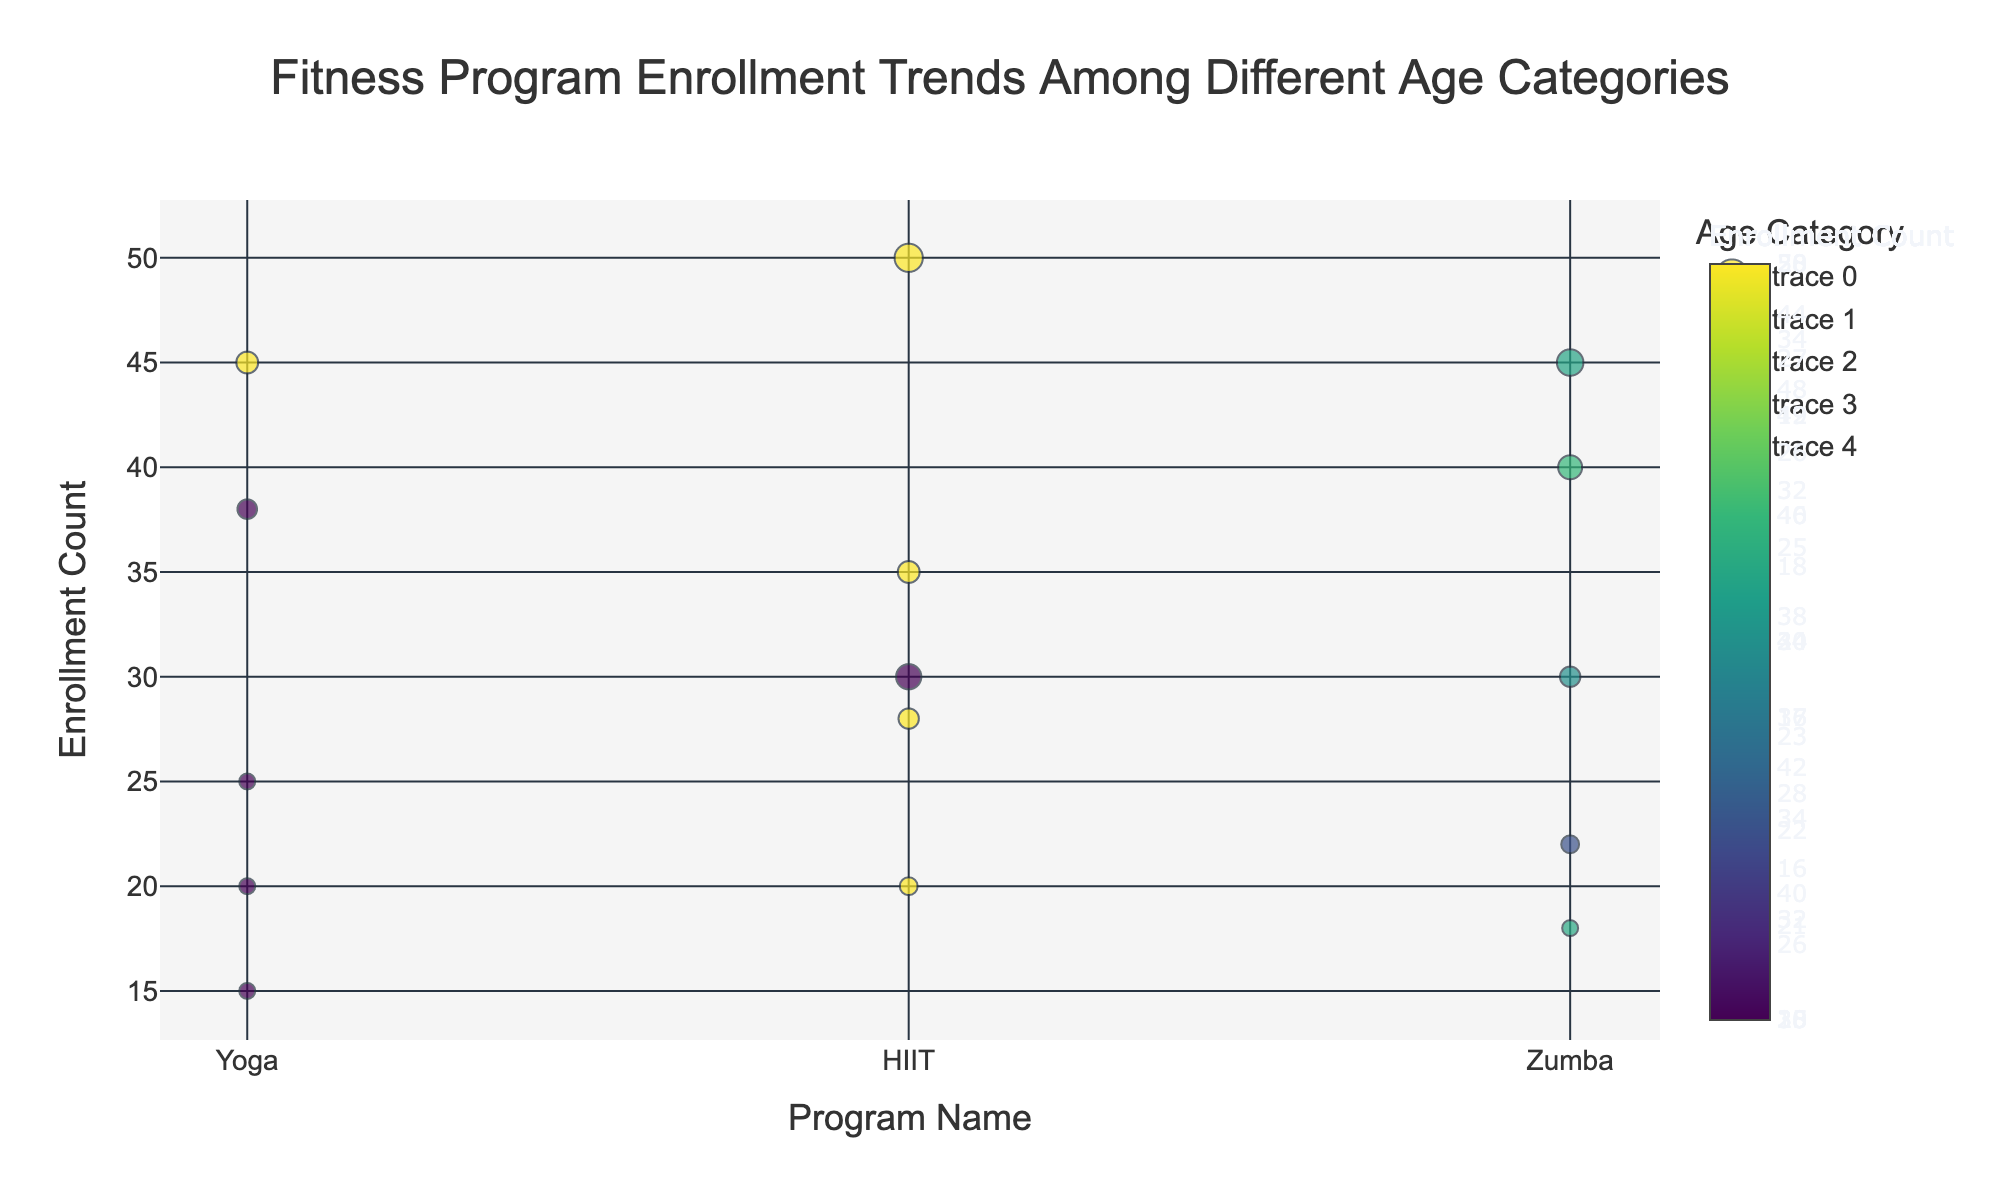What is the title of the bubble chart? The title of the chart is displayed at the top center of the chart. It reads "Fitness Program Enrollment Trends Among Different Age Categories".
Answer: Fitness Program Enrollment Trends Among Different Age Categories Which program has the highest enrollment count for the 26-35 age category? To answer this, look at the '26-35' age category group bubbles and compare their sizes and y-positions. "HIIT" has the highest enrollment count of 50 within this age category.
Answer: HIIT What is the enrollment count for Zumba in the 18-25 age category? Find the bubble for Zumba in the 18-25 age category and note its y-position, which represents the enrollment count. The enrollment count for Zumba in this age category is 40.
Answer: 40 Which age category has the smallest enrollment in Yoga programs and what is that count? Identify the bubbles for Yoga across all age categories, then compare their y-positions to determine the smallest one. The '56-65' age category has the smallest enrollment count of 15 for Yoga.
Answer: 56-65, 15 How does the budget allocated for HIIT in the 36-45 age category compare to that in the 26-35 age category? Look at the sizes of the bubbles representing HIIT for the 36-45 and 26-35 age categories. The size of the bubble indicates the budget, where the 26-35 age category ($2500) has a larger budget compared to the 36-45 age category ($1500).
Answer: 26-35: $2500, 36-45: $1500 Which program for the 46-55 age category has the largest bubble, and what does this represent? The bubble size for each program represents the budget allocated. For the 46-55 age category, find the largest bubble. "HIIT" has the largest bubble indicating a budget of $1300.
Answer: HIIT, $1300 What is the average enrollment count for Yoga across all age categories? Sum the enrollment counts for Yoga (45 + 38 + 25 + 20 + 15) and divide by the number of age categories (5). This results in (45+38+25+20+15)/5 = 28.6.
Answer: 28.6 Which age category shows a consistent decrease in enrollment counts across all three programs? Review enrollment trends by examining the y-position of bubbles for each program across age categories. The 56-65 age category consistently has the lowest enrollment counts for Yoga (15), HIIT (20), and Zumba (18).
Answer: 56-65 What is the total budget allocated for Zumba across all age categories? Sum the budgets for Zumba across all age categories: $1800 (18-25) + $2200 (26-35) + $1300 (36-45) + $1000 (46-55) + $800 (56-65). The total is $7100.
Answer: $7100 Which program in the 36-45 age category has the highest enrollment count and how much budget is allocated for it? Check the y-positions and bubble sizes for the 36-45 age category. HIIT has the highest enrollment count (35) with a budget allocated of $1500.
Answer: HIIT, $1500 